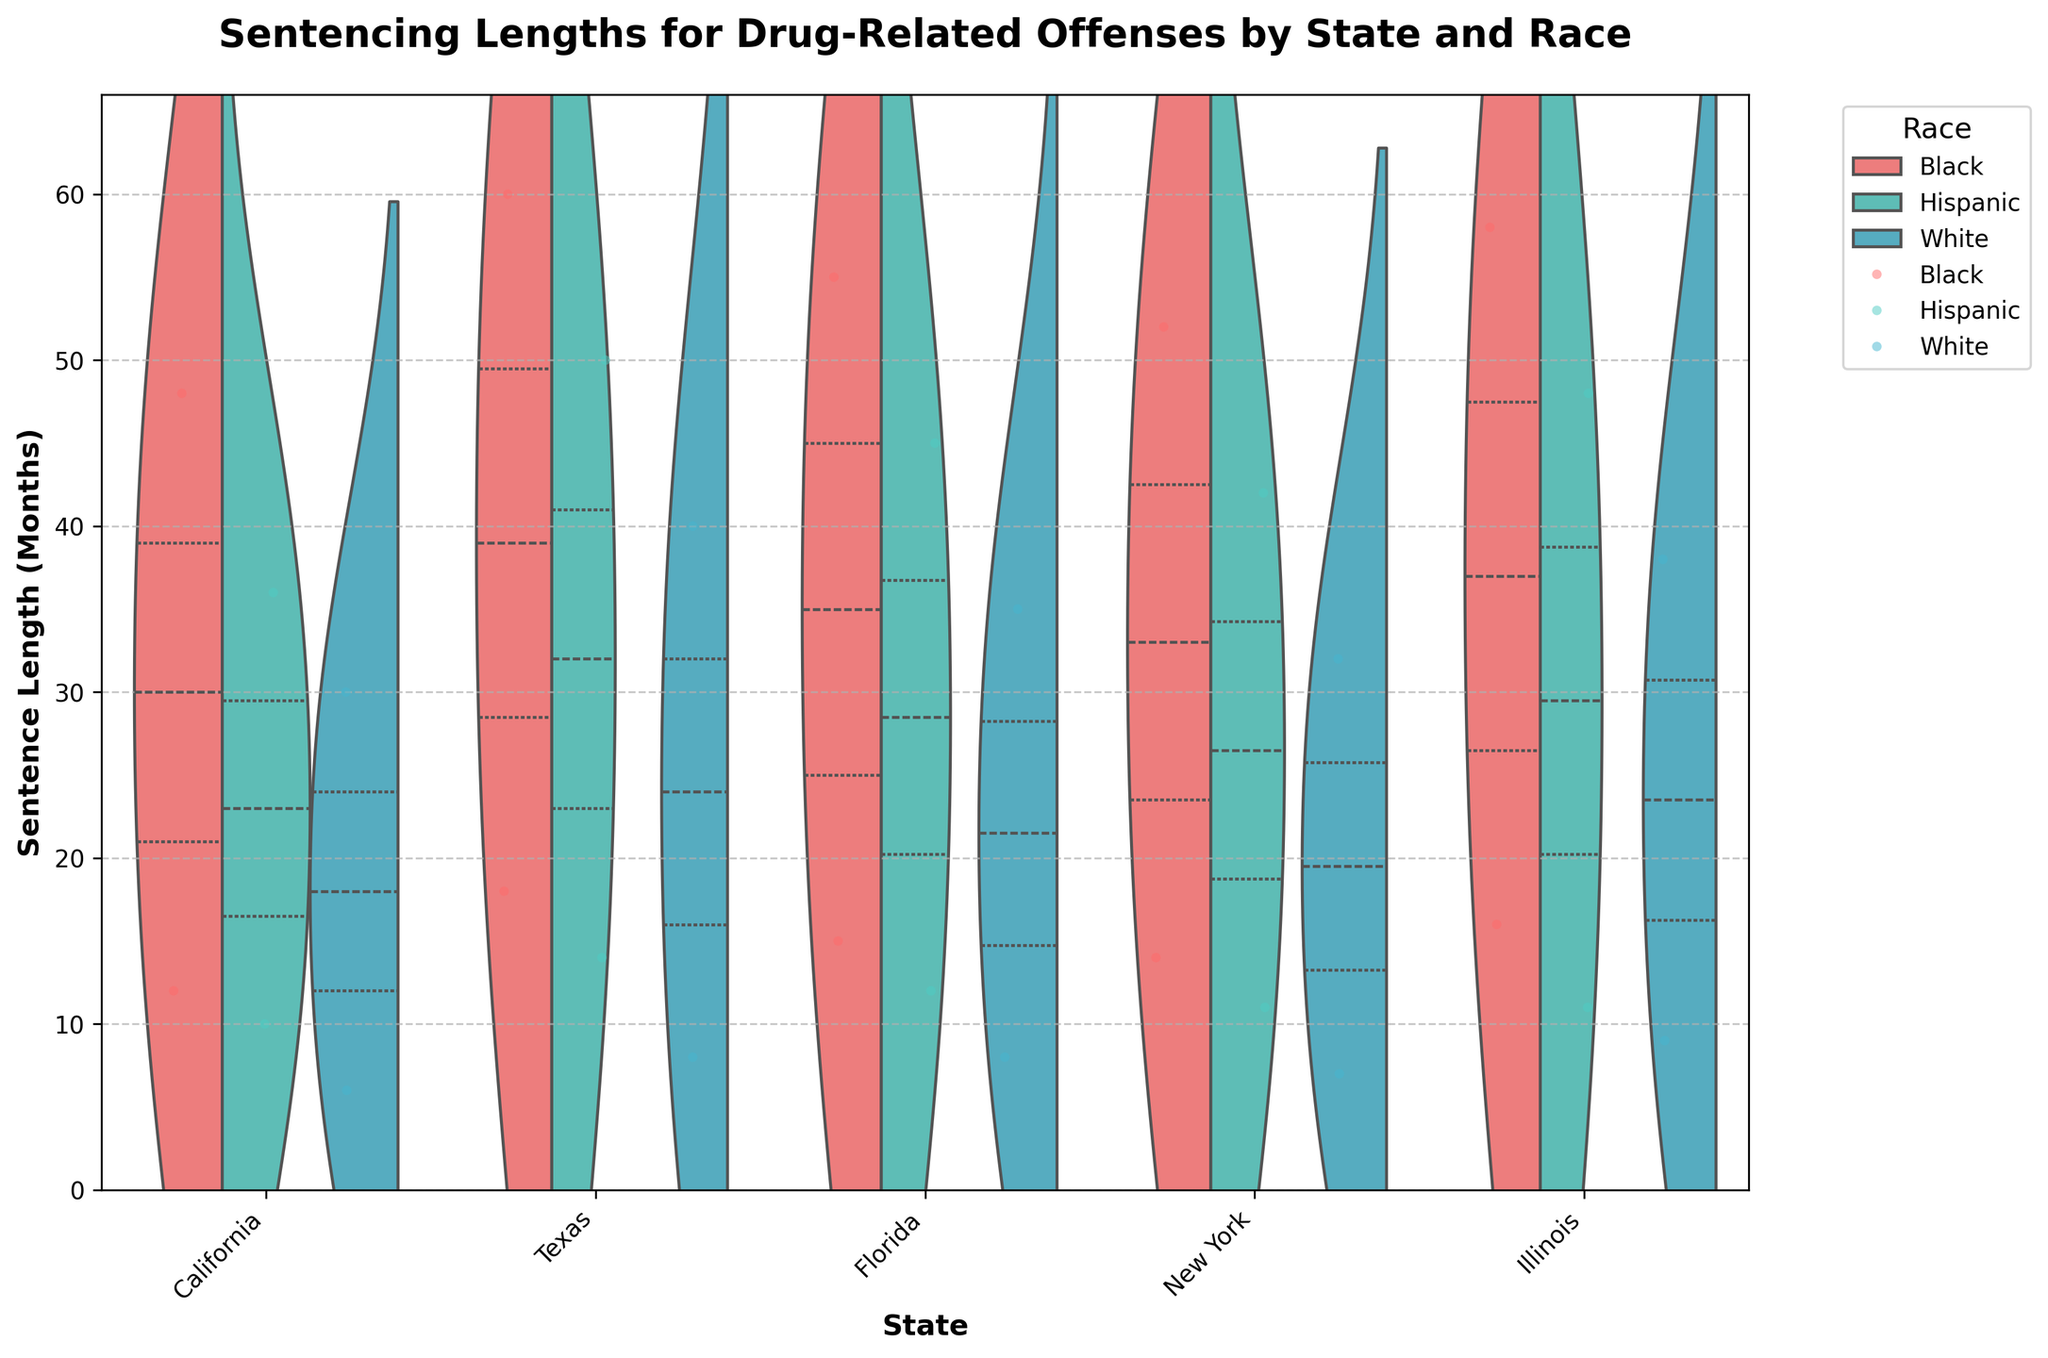What title is used for the violin chart? The title is written at the top of the chart, and it summarizes the chart's content.
Answer: Sentencing Lengths for Drug-Related Offenses by State and Race What are the labeled axes on the chart? The x-axis indicates the various states, and the y-axis represents the sentence length in months.
Answer: State, Sentence Length (Months) Which racial group appears to have the longest average sentence length in Texas? By looking at the median lines within the Texas violin plots, it is evident that the red lines (representing Black individuals) extend higher than those for Hispanics and Whites.
Answer: Black Which state shows the least variability in sentencing lengths for White individuals? The width and spread of the violin plot for White individuals should be examined; California's violin plot for Whites appears narrower and more compact than the others.
Answer: California In which state do Hispanic individuals receive the longest sentences on average for simple possession? Compare the median lines within each state's violin plot for Hispanic individuals specifically focusing on simple possession (the lower distribution for each state); Texas appears to have a higher median line for Hispanics in simple possession.
Answer: Texas How do the sentence lengths for drug trafficking compare between Black and White individuals in Illinois? By examining the two halves of the violin plot for Illinois, the median for Black individuals (marked in red) is higher than the median for White individuals (marked in blue).
Answer: Longer for Black individuals What is the difference in the average sentence length between Hispanic and White individuals for drug trafficking in Florida? Look at the median lines in the Florida violin plot for trafficking; the median for Hispanics (green) is about 45 months and for Whites (blue) is about 35 months. The difference is 45 - 35 = 10 months.
Answer: 10 months In which state is the disparity between sentence lengths for Black and Hispanic individuals the smallest? Compare the gaps between median lines for Black and Hispanic individuals across all states; New York shows the smallest disparity.
Answer: New York Are the sentence lengths for Black individuals generally higher across all states for trafficking offenses? Examine the upper portions of each state's violin plot for Trafficking where Black individuals (red) usually have a higher median and upper distribution.
Answer: Yes Which state shows the greatest overall variability in sentencing lengths for drug-related offenses? Evaluating the width and spread of the violin plots; Illinois has the widest and most variable plots.
Answer: Illinois 